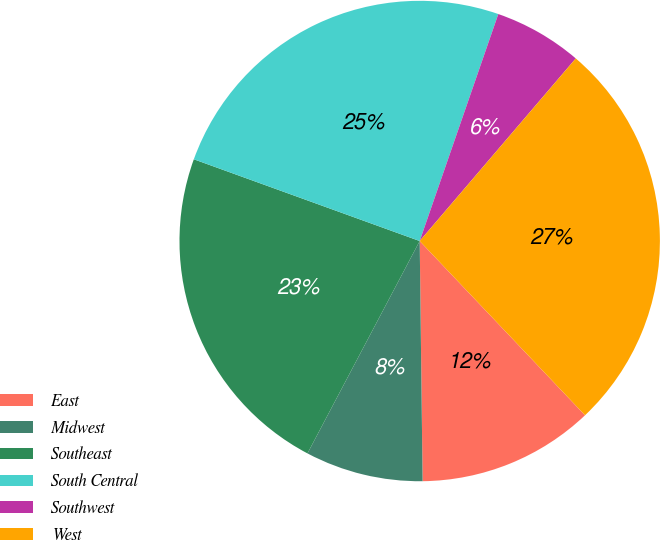Convert chart to OTSL. <chart><loc_0><loc_0><loc_500><loc_500><pie_chart><fcel>East<fcel>Midwest<fcel>Southeast<fcel>South Central<fcel>Southwest<fcel>West<nl><fcel>11.89%<fcel>7.93%<fcel>22.79%<fcel>24.78%<fcel>5.95%<fcel>26.66%<nl></chart> 